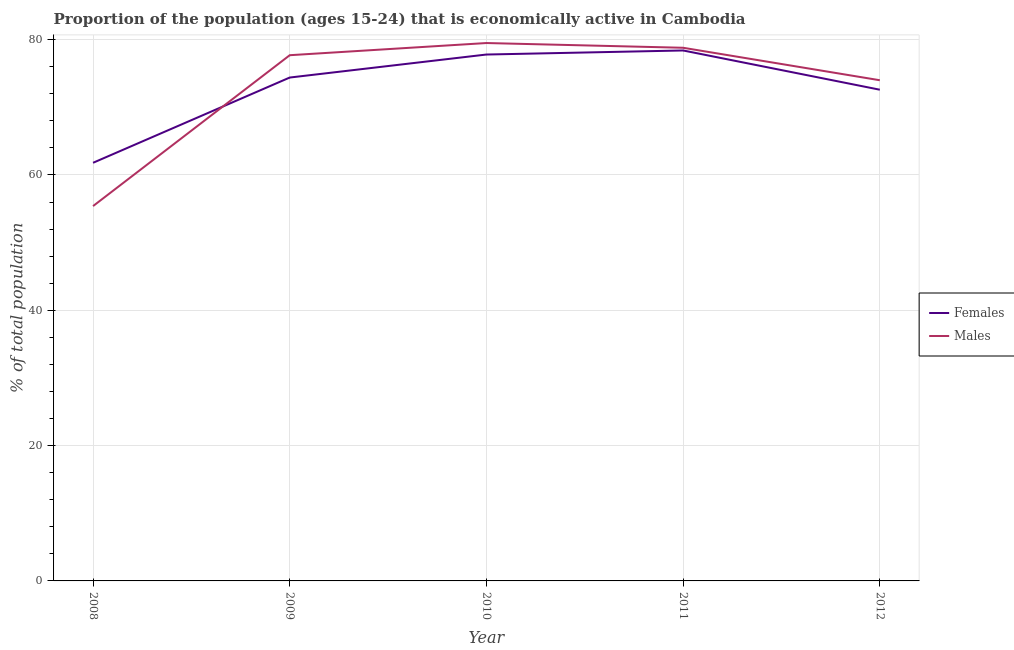How many different coloured lines are there?
Offer a very short reply. 2. Is the number of lines equal to the number of legend labels?
Give a very brief answer. Yes. What is the percentage of economically active male population in 2009?
Give a very brief answer. 77.7. Across all years, what is the maximum percentage of economically active male population?
Your answer should be very brief. 79.5. Across all years, what is the minimum percentage of economically active male population?
Offer a terse response. 55.4. In which year was the percentage of economically active male population minimum?
Your answer should be compact. 2008. What is the total percentage of economically active male population in the graph?
Make the answer very short. 365.4. What is the difference between the percentage of economically active male population in 2008 and that in 2009?
Make the answer very short. -22.3. What is the difference between the percentage of economically active male population in 2011 and the percentage of economically active female population in 2008?
Your answer should be compact. 17. What is the average percentage of economically active male population per year?
Give a very brief answer. 73.08. In the year 2011, what is the difference between the percentage of economically active male population and percentage of economically active female population?
Provide a short and direct response. 0.4. In how many years, is the percentage of economically active male population greater than 24 %?
Ensure brevity in your answer.  5. What is the ratio of the percentage of economically active male population in 2008 to that in 2012?
Make the answer very short. 0.75. What is the difference between the highest and the second highest percentage of economically active female population?
Give a very brief answer. 0.6. What is the difference between the highest and the lowest percentage of economically active male population?
Provide a succinct answer. 24.1. Is the sum of the percentage of economically active female population in 2009 and 2010 greater than the maximum percentage of economically active male population across all years?
Your answer should be very brief. Yes. Are the values on the major ticks of Y-axis written in scientific E-notation?
Offer a terse response. No. Does the graph contain any zero values?
Your answer should be compact. No. Does the graph contain grids?
Your response must be concise. Yes. How many legend labels are there?
Provide a short and direct response. 2. How are the legend labels stacked?
Provide a short and direct response. Vertical. What is the title of the graph?
Offer a terse response. Proportion of the population (ages 15-24) that is economically active in Cambodia. Does "State government" appear as one of the legend labels in the graph?
Your response must be concise. No. What is the label or title of the Y-axis?
Offer a very short reply. % of total population. What is the % of total population of Females in 2008?
Provide a succinct answer. 61.8. What is the % of total population in Males in 2008?
Your answer should be very brief. 55.4. What is the % of total population of Females in 2009?
Make the answer very short. 74.4. What is the % of total population of Males in 2009?
Your response must be concise. 77.7. What is the % of total population in Females in 2010?
Give a very brief answer. 77.8. What is the % of total population in Males in 2010?
Offer a very short reply. 79.5. What is the % of total population in Females in 2011?
Ensure brevity in your answer.  78.4. What is the % of total population of Males in 2011?
Make the answer very short. 78.8. What is the % of total population in Females in 2012?
Offer a very short reply. 72.6. What is the % of total population of Males in 2012?
Keep it short and to the point. 74. Across all years, what is the maximum % of total population in Females?
Provide a succinct answer. 78.4. Across all years, what is the maximum % of total population of Males?
Keep it short and to the point. 79.5. Across all years, what is the minimum % of total population in Females?
Your answer should be very brief. 61.8. Across all years, what is the minimum % of total population in Males?
Keep it short and to the point. 55.4. What is the total % of total population in Females in the graph?
Keep it short and to the point. 365. What is the total % of total population in Males in the graph?
Provide a short and direct response. 365.4. What is the difference between the % of total population in Females in 2008 and that in 2009?
Give a very brief answer. -12.6. What is the difference between the % of total population in Males in 2008 and that in 2009?
Your answer should be very brief. -22.3. What is the difference between the % of total population of Males in 2008 and that in 2010?
Provide a succinct answer. -24.1. What is the difference between the % of total population in Females in 2008 and that in 2011?
Your response must be concise. -16.6. What is the difference between the % of total population of Males in 2008 and that in 2011?
Ensure brevity in your answer.  -23.4. What is the difference between the % of total population of Females in 2008 and that in 2012?
Provide a succinct answer. -10.8. What is the difference between the % of total population in Males in 2008 and that in 2012?
Provide a short and direct response. -18.6. What is the difference between the % of total population of Males in 2009 and that in 2010?
Make the answer very short. -1.8. What is the difference between the % of total population of Females in 2009 and that in 2011?
Offer a terse response. -4. What is the difference between the % of total population of Females in 2010 and that in 2011?
Offer a terse response. -0.6. What is the difference between the % of total population in Males in 2010 and that in 2012?
Offer a terse response. 5.5. What is the difference between the % of total population of Females in 2011 and that in 2012?
Offer a terse response. 5.8. What is the difference between the % of total population in Females in 2008 and the % of total population in Males in 2009?
Provide a succinct answer. -15.9. What is the difference between the % of total population of Females in 2008 and the % of total population of Males in 2010?
Offer a terse response. -17.7. What is the difference between the % of total population of Females in 2008 and the % of total population of Males in 2011?
Offer a terse response. -17. What is the difference between the % of total population of Females in 2008 and the % of total population of Males in 2012?
Give a very brief answer. -12.2. What is the difference between the % of total population of Females in 2009 and the % of total population of Males in 2010?
Give a very brief answer. -5.1. What is the difference between the % of total population in Females in 2010 and the % of total population in Males in 2011?
Ensure brevity in your answer.  -1. What is the difference between the % of total population of Females in 2011 and the % of total population of Males in 2012?
Make the answer very short. 4.4. What is the average % of total population in Males per year?
Provide a succinct answer. 73.08. In the year 2009, what is the difference between the % of total population in Females and % of total population in Males?
Your answer should be compact. -3.3. What is the ratio of the % of total population of Females in 2008 to that in 2009?
Provide a short and direct response. 0.83. What is the ratio of the % of total population of Males in 2008 to that in 2009?
Make the answer very short. 0.71. What is the ratio of the % of total population of Females in 2008 to that in 2010?
Keep it short and to the point. 0.79. What is the ratio of the % of total population of Males in 2008 to that in 2010?
Provide a short and direct response. 0.7. What is the ratio of the % of total population of Females in 2008 to that in 2011?
Provide a short and direct response. 0.79. What is the ratio of the % of total population in Males in 2008 to that in 2011?
Ensure brevity in your answer.  0.7. What is the ratio of the % of total population in Females in 2008 to that in 2012?
Offer a terse response. 0.85. What is the ratio of the % of total population in Males in 2008 to that in 2012?
Your answer should be very brief. 0.75. What is the ratio of the % of total population in Females in 2009 to that in 2010?
Make the answer very short. 0.96. What is the ratio of the % of total population in Males in 2009 to that in 2010?
Offer a terse response. 0.98. What is the ratio of the % of total population of Females in 2009 to that in 2011?
Make the answer very short. 0.95. What is the ratio of the % of total population in Females in 2009 to that in 2012?
Provide a short and direct response. 1.02. What is the ratio of the % of total population in Males in 2009 to that in 2012?
Provide a succinct answer. 1.05. What is the ratio of the % of total population of Females in 2010 to that in 2011?
Provide a succinct answer. 0.99. What is the ratio of the % of total population in Males in 2010 to that in 2011?
Ensure brevity in your answer.  1.01. What is the ratio of the % of total population in Females in 2010 to that in 2012?
Offer a terse response. 1.07. What is the ratio of the % of total population of Males in 2010 to that in 2012?
Provide a short and direct response. 1.07. What is the ratio of the % of total population in Females in 2011 to that in 2012?
Make the answer very short. 1.08. What is the ratio of the % of total population of Males in 2011 to that in 2012?
Keep it short and to the point. 1.06. What is the difference between the highest and the second highest % of total population of Males?
Keep it short and to the point. 0.7. What is the difference between the highest and the lowest % of total population of Males?
Your response must be concise. 24.1. 